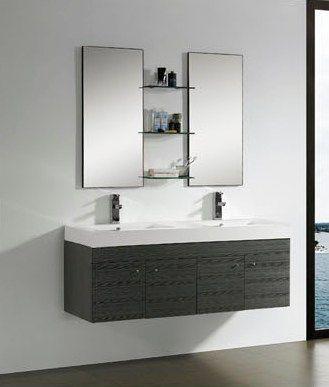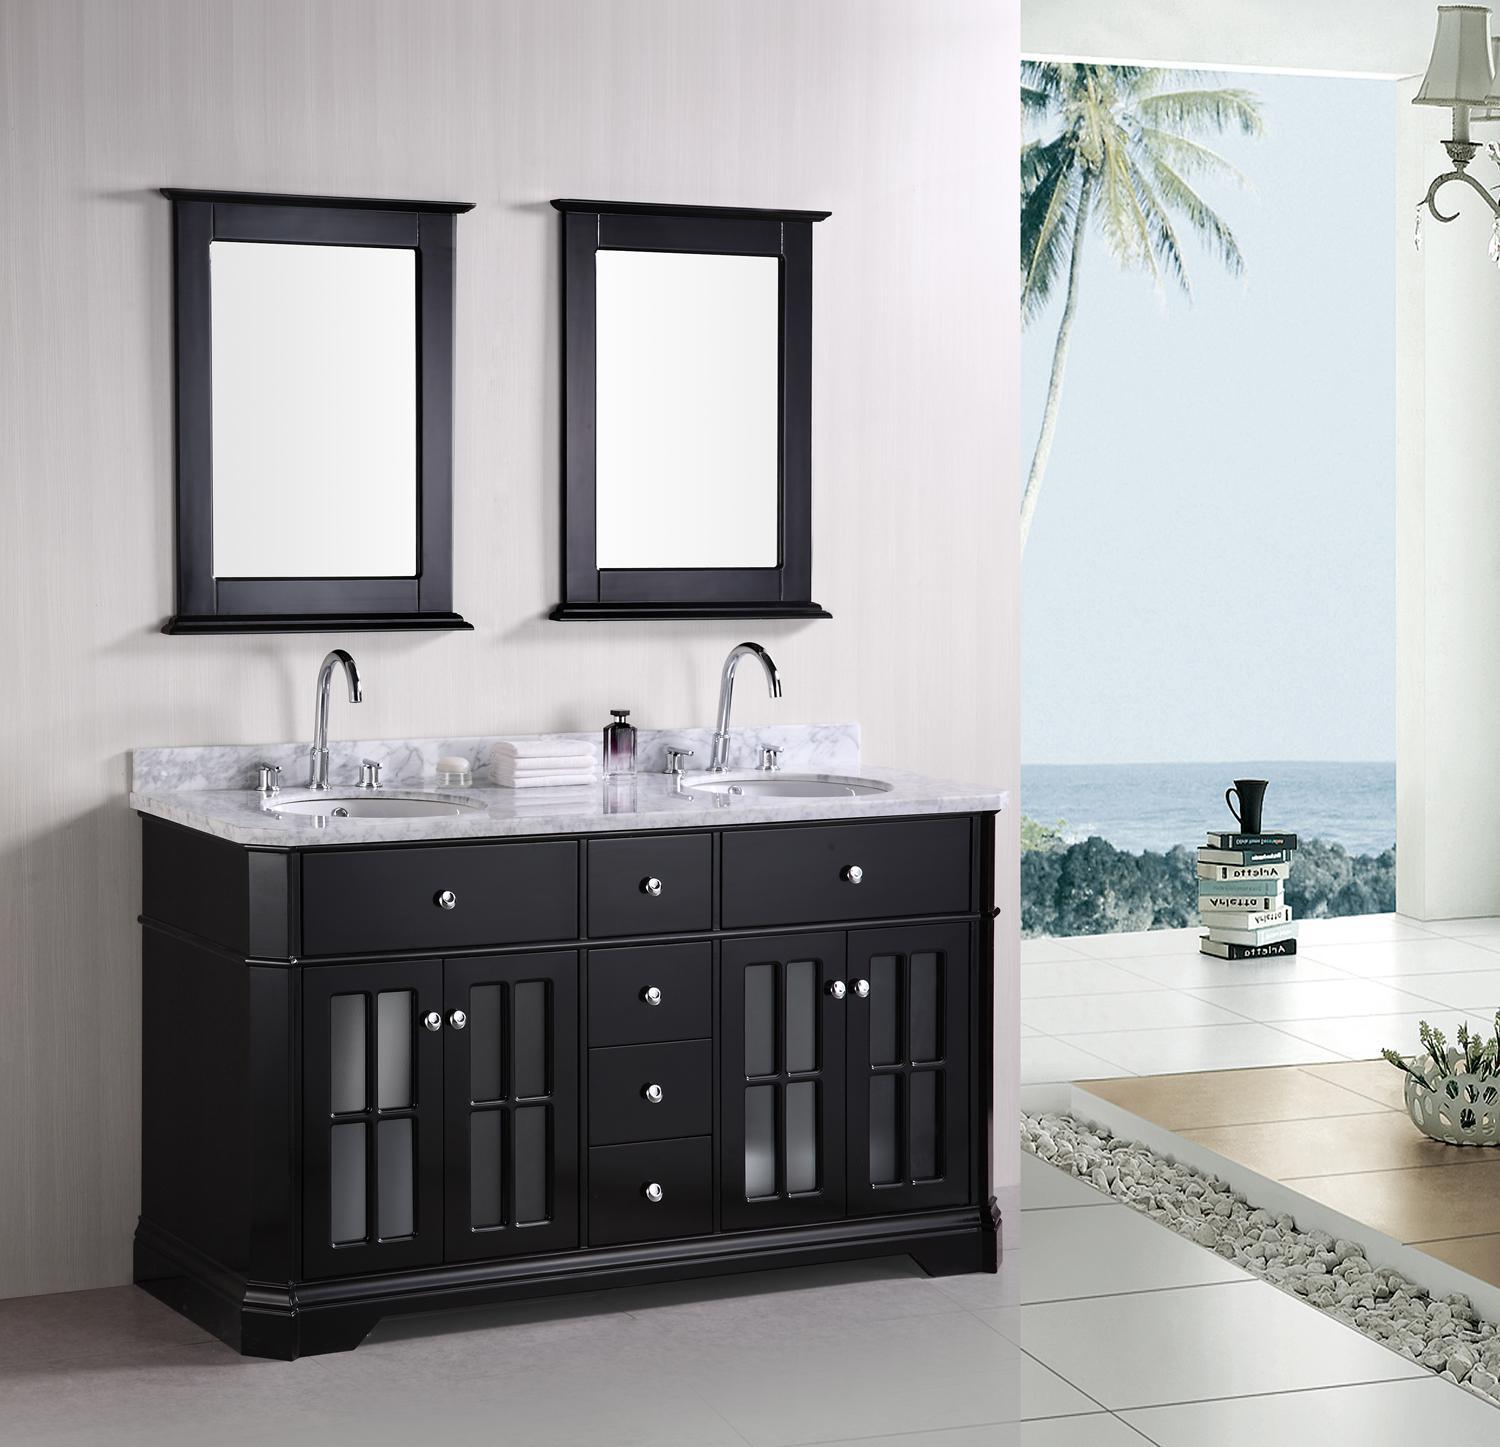The first image is the image on the left, the second image is the image on the right. Given the left and right images, does the statement "In one image, one large mirror is positioned over a long open wooden vanity on feet with two matching white sinks." hold true? Answer yes or no. No. The first image is the image on the left, the second image is the image on the right. Considering the images on both sides, is "The vanity in the right-hand image features a pair of squarish white basins sitting on top." valid? Answer yes or no. No. 